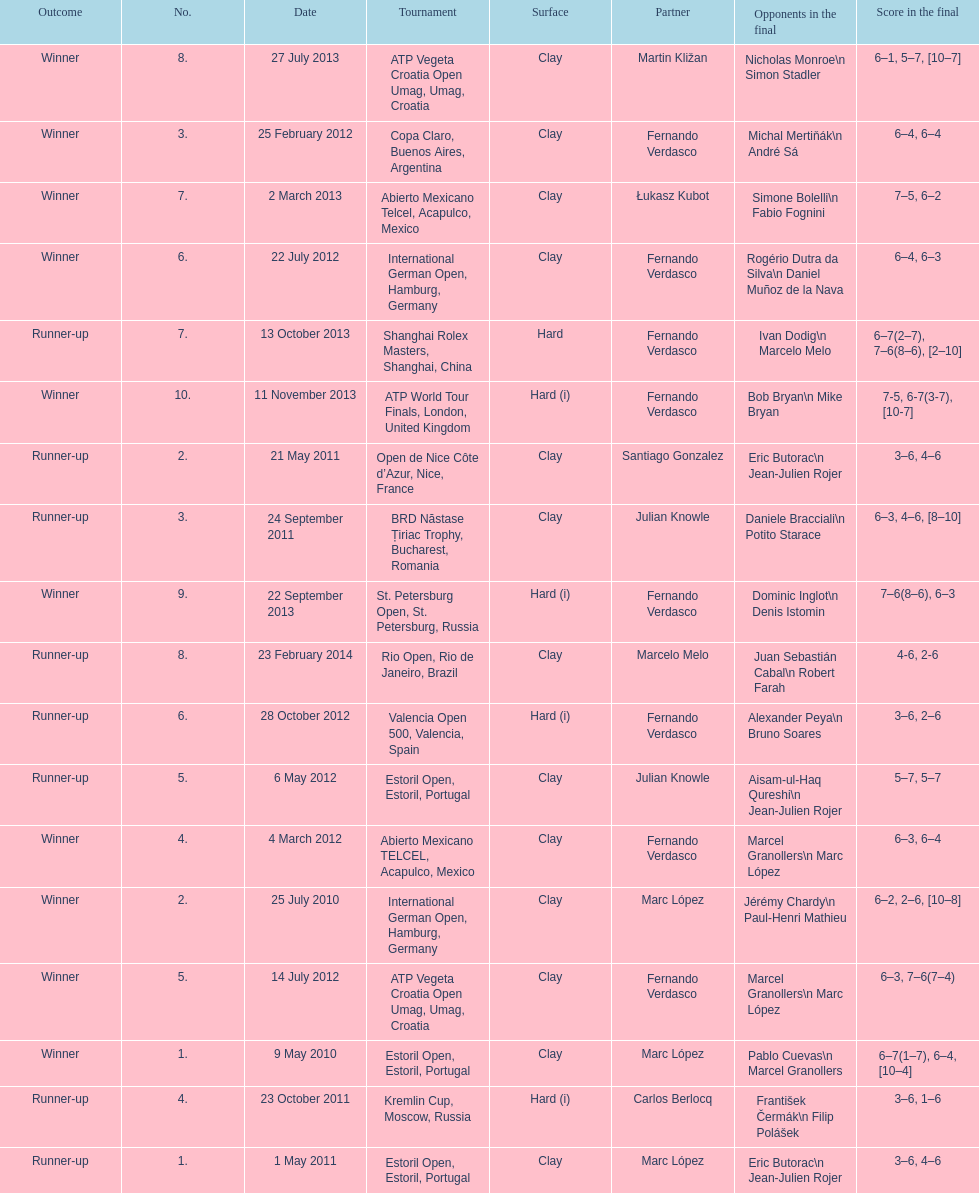Who won both the st.petersburg open and the atp world tour finals? Fernando Verdasco. 